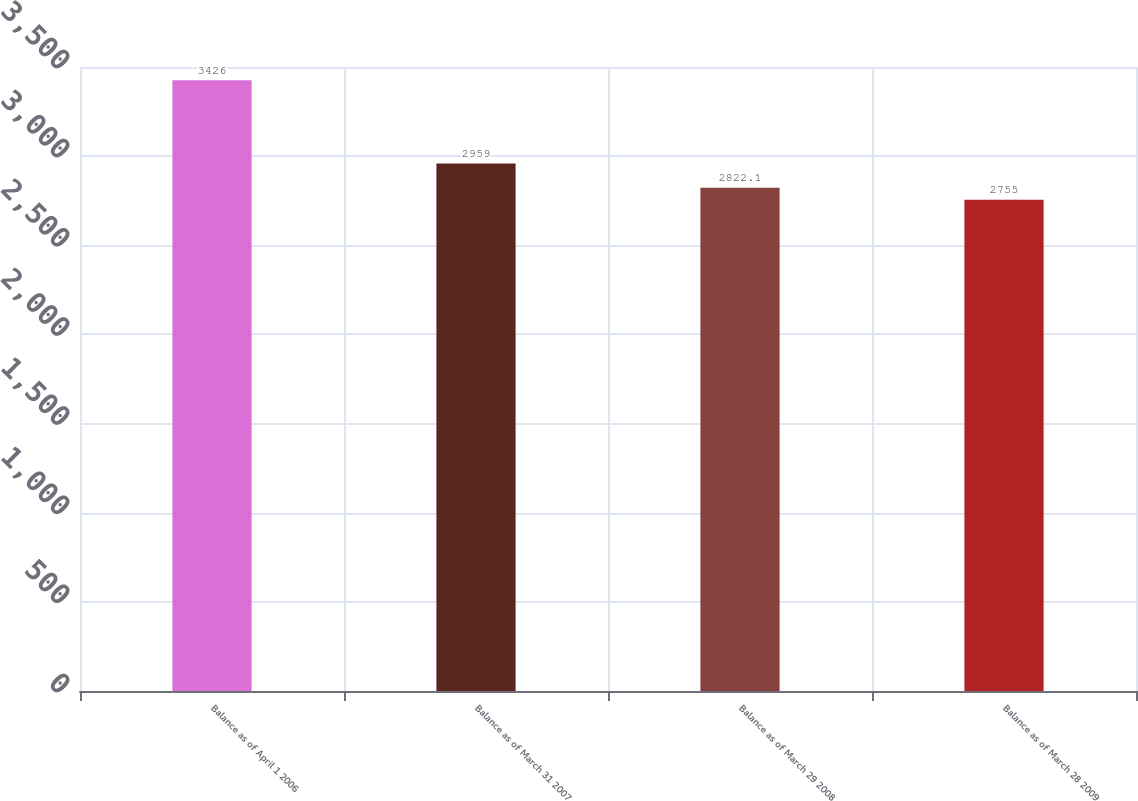Convert chart to OTSL. <chart><loc_0><loc_0><loc_500><loc_500><bar_chart><fcel>Balance as of April 1 2006<fcel>Balance as of March 31 2007<fcel>Balance as of March 29 2008<fcel>Balance as of March 28 2009<nl><fcel>3426<fcel>2959<fcel>2822.1<fcel>2755<nl></chart> 